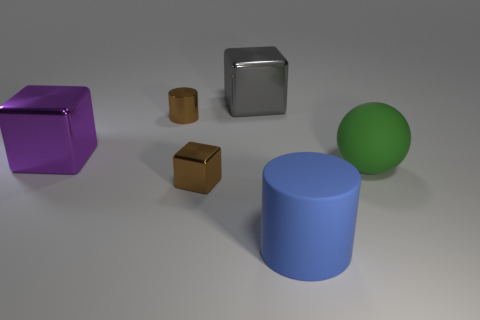Are the large gray object and the blue thing made of the same material? Based on the visual characteristics of the objects in the image, it's likely that they are not made of the same material. The large gray object has a reflective metallic finish that suggests it could be made of metal, while the blue object has a matte finish that could indicate it's made from plastic or another non-metallic material. 